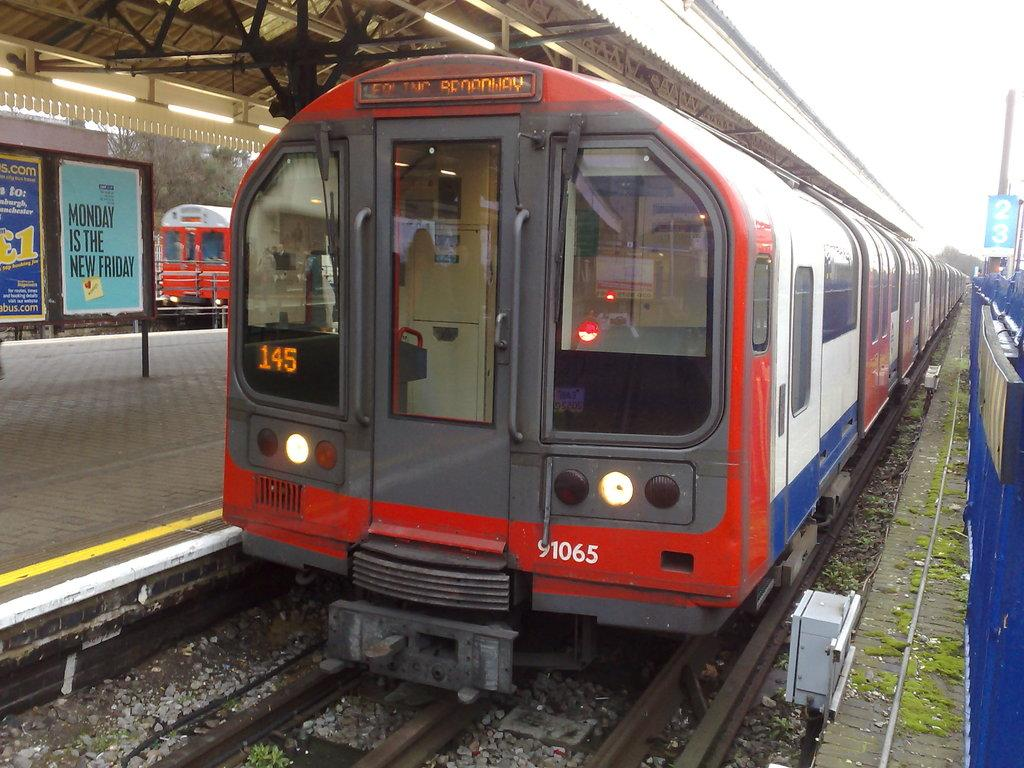What type of vehicles can be seen on the railway tracks in the image? There are trains on the railway tracks in the image. What is located near the railway tracks? There is a platform in the image. What objects are present in the image that might provide information or direction? There are boards in the image. What can be seen in the image that might provide illumination? There are lights in the image. What type of fruit is being sold by the slaves on the platform in the image? There is no mention of slaves or fruit in the image; it features trains on railway tracks, a platform, boards, and lights. 